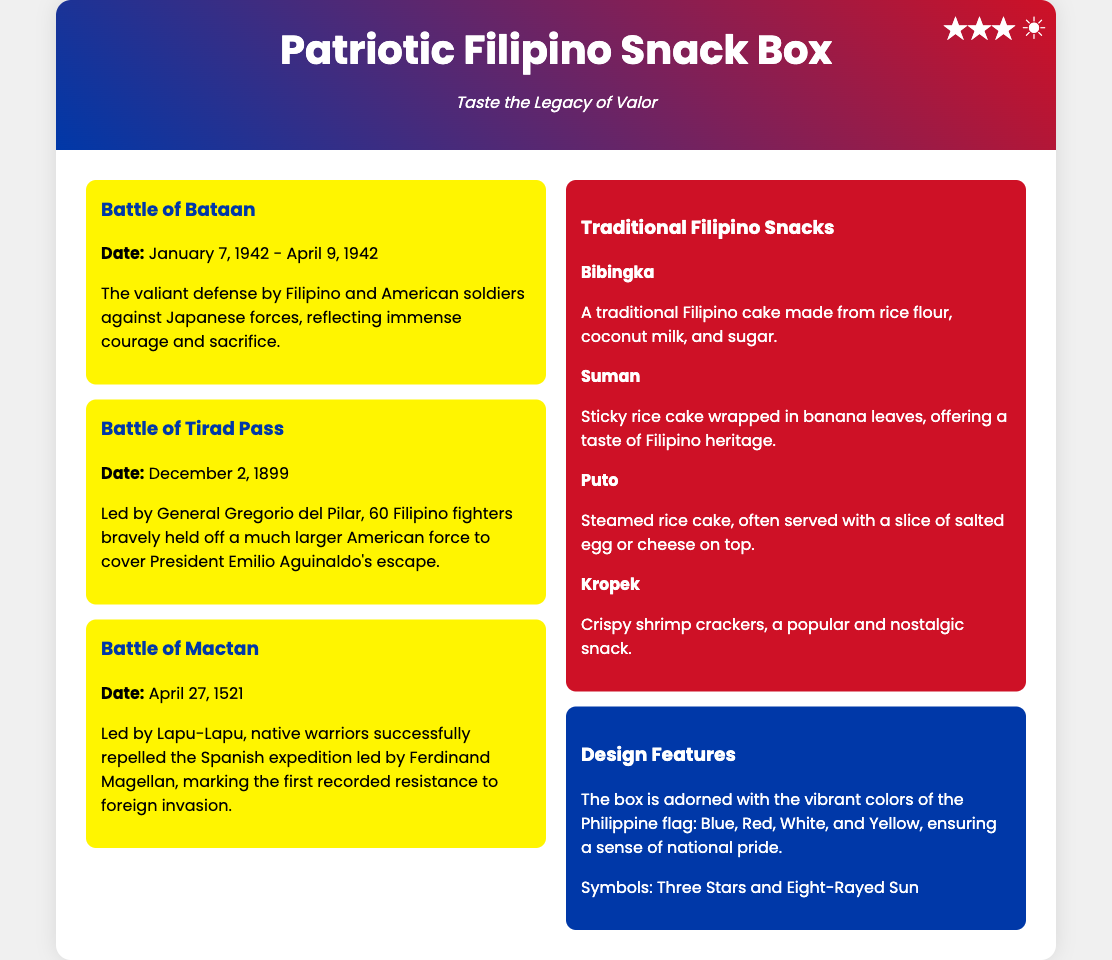What is the title of the product? The title of the product is displayed prominently at the top of the packaging.
Answer: Patriotic Filipino Snack Box What are the colors adorning the box? The document describes the vibrant colors associated with the Philippine flag that adorn the box.
Answer: Blue, Red, White, Yellow What is the tagline of the product? The tagline is presented below the title in a stylized manner to evoke emotion.
Answer: Taste the Legacy of Valor Who led the Battle of Tirad Pass? The document provides the name of the leader for this significant battle in history.
Answer: General Gregorio del Pilar What snack is described as a traditional Filipino cake made from rice flour? This description is given for one of the snacks listed in the document.
Answer: Bibingka In what year did the Battle of Mactan occur? The document explicitly states the date of this important military encounter.
Answer: 1521 How many significant battles are mentioned in the document? The number of battles highlighted in the left column informs this answer.
Answer: Three What type of snack is Suman? The document categorizes this snack based on its preparation method.
Answer: Sticky rice cake What symbol is featured on the box representing the Philippines? The document mentions specific symbols used in the design of the packaging.
Answer: Three Stars and Eight-Rayed Sun 